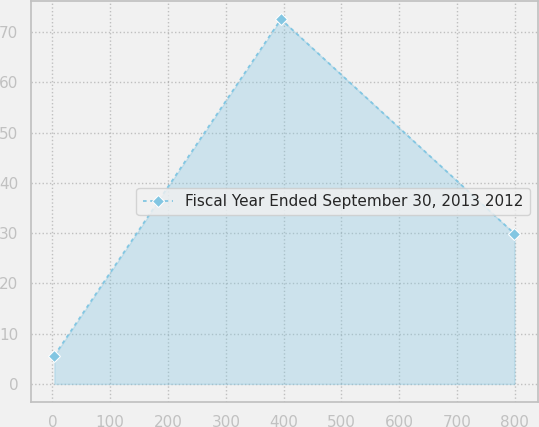Convert chart. <chart><loc_0><loc_0><loc_500><loc_500><line_chart><ecel><fcel>Fiscal Year Ended September 30, 2013 2012<nl><fcel>3.36<fcel>5.64<nl><fcel>395.25<fcel>72.58<nl><fcel>799.34<fcel>29.88<nl></chart> 